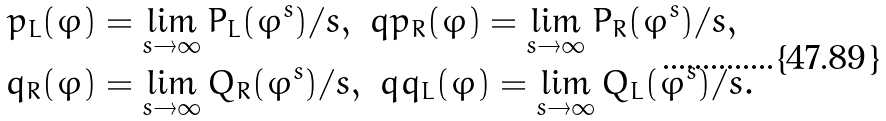<formula> <loc_0><loc_0><loc_500><loc_500>p _ { L } ( \varphi ) & = \lim _ { s \to \infty } P _ { L } ( \varphi ^ { s } ) / s , \ q p _ { R } ( \varphi ) = \lim _ { s \to \infty } P _ { R } ( \varphi ^ { s } ) / s , \\ q _ { R } ( \varphi ) & = \lim _ { s \to \infty } Q _ { R } ( \varphi ^ { s } ) / s , \ q q _ { L } ( \varphi ) = \lim _ { s \to \infty } Q _ { L } ( \varphi ^ { s } ) / s .</formula> 